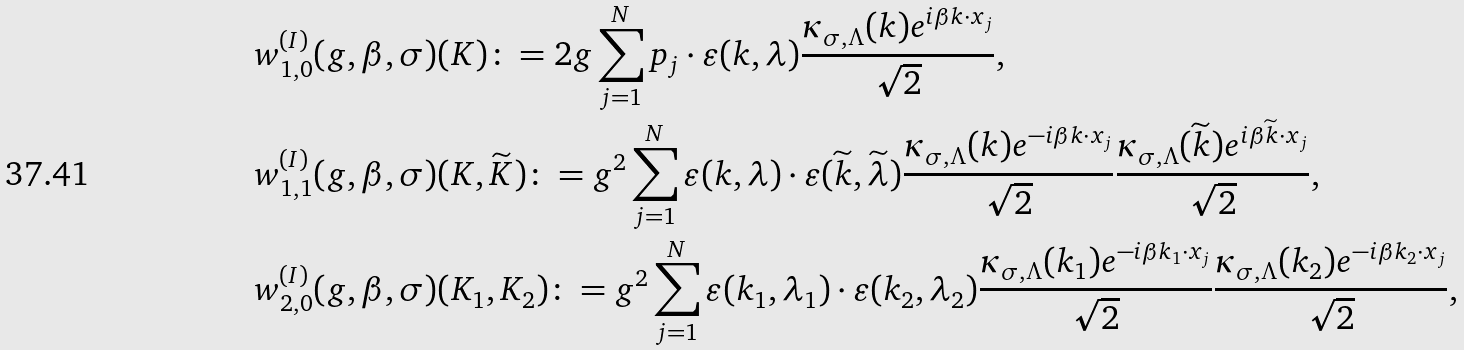<formula> <loc_0><loc_0><loc_500><loc_500>& w ^ { ( I ) } _ { 1 , 0 } ( g , \beta , \sigma ) ( K ) \colon = 2 g \sum _ { j = 1 } ^ { N } p _ { j } \cdot \varepsilon ( k , \lambda ) \frac { \kappa _ { \sigma , \Lambda } ( k ) e ^ { i \beta k \cdot x _ { j } } } { \sqrt { 2 } } , \\ & w ^ { ( I ) } _ { 1 , 1 } ( g , \beta , \sigma ) ( K , \widetilde { K } ) \colon = g ^ { 2 } \sum _ { j = 1 } ^ { N } \varepsilon ( k , \lambda ) \cdot \varepsilon ( \widetilde { k } , \widetilde { \lambda } ) \frac { \kappa _ { \sigma , \Lambda } ( k ) e ^ { - i \beta k \cdot x _ { j } } } { \sqrt { 2 } } \frac { \kappa _ { \sigma , \Lambda } ( \widetilde { k } ) e ^ { i \beta \widetilde { k } \cdot x _ { j } } } { \sqrt { 2 } } , \\ & w ^ { ( I ) } _ { 2 , 0 } ( g , \beta , \sigma ) ( K _ { 1 } , K _ { 2 } ) \colon = g ^ { 2 } \sum _ { j = 1 } ^ { N } \varepsilon ( k _ { 1 } , \lambda _ { 1 } ) \cdot \varepsilon ( { k } _ { 2 } , { \lambda } _ { 2 } ) \frac { \kappa _ { \sigma , \Lambda } ( k _ { 1 } ) e ^ { - i \beta k _ { 1 } \cdot x _ { j } } } { \sqrt { 2 } } \frac { \kappa _ { \sigma , \Lambda } ( k _ { 2 } ) e ^ { - i \beta k _ { 2 } \cdot x _ { j } } } { \sqrt { 2 } } ,</formula> 